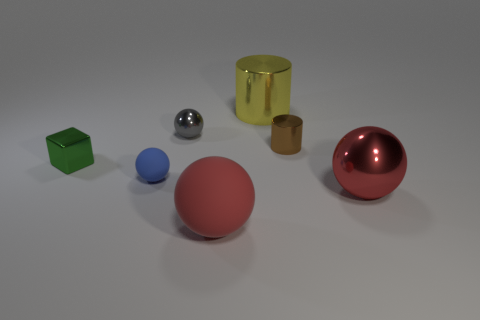Subtract 1 balls. How many balls are left? 3 Add 2 large brown spheres. How many objects exist? 9 Subtract all blocks. How many objects are left? 6 Subtract all small yellow metallic things. Subtract all blue rubber objects. How many objects are left? 6 Add 7 gray metal objects. How many gray metal objects are left? 8 Add 5 big purple metal cylinders. How many big purple metal cylinders exist? 5 Subtract 0 gray cubes. How many objects are left? 7 